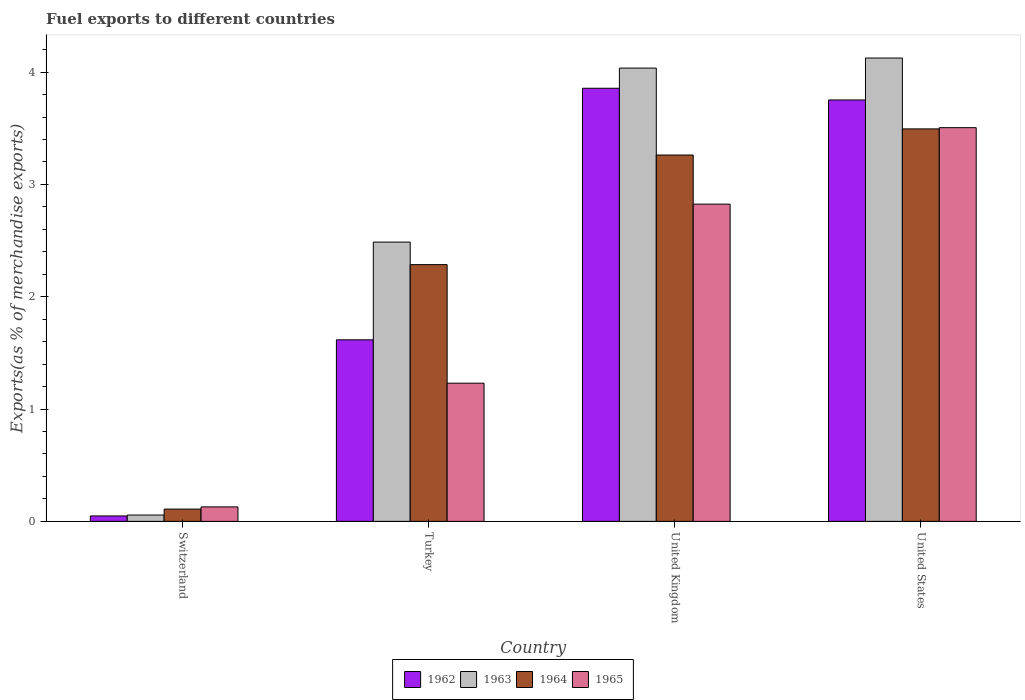Are the number of bars on each tick of the X-axis equal?
Offer a terse response. Yes. In how many cases, is the number of bars for a given country not equal to the number of legend labels?
Your answer should be compact. 0. What is the percentage of exports to different countries in 1965 in Turkey?
Your answer should be compact. 1.23. Across all countries, what is the maximum percentage of exports to different countries in 1962?
Offer a terse response. 3.86. Across all countries, what is the minimum percentage of exports to different countries in 1962?
Offer a very short reply. 0.05. In which country was the percentage of exports to different countries in 1962 maximum?
Make the answer very short. United Kingdom. In which country was the percentage of exports to different countries in 1962 minimum?
Ensure brevity in your answer.  Switzerland. What is the total percentage of exports to different countries in 1963 in the graph?
Offer a very short reply. 10.7. What is the difference between the percentage of exports to different countries in 1962 in Switzerland and that in United Kingdom?
Keep it short and to the point. -3.81. What is the difference between the percentage of exports to different countries in 1964 in United States and the percentage of exports to different countries in 1965 in United Kingdom?
Give a very brief answer. 0.67. What is the average percentage of exports to different countries in 1963 per country?
Make the answer very short. 2.68. What is the difference between the percentage of exports to different countries of/in 1965 and percentage of exports to different countries of/in 1963 in United States?
Make the answer very short. -0.62. What is the ratio of the percentage of exports to different countries in 1963 in Switzerland to that in United States?
Keep it short and to the point. 0.01. Is the difference between the percentage of exports to different countries in 1965 in Switzerland and United Kingdom greater than the difference between the percentage of exports to different countries in 1963 in Switzerland and United Kingdom?
Offer a terse response. Yes. What is the difference between the highest and the second highest percentage of exports to different countries in 1963?
Your response must be concise. -1.64. What is the difference between the highest and the lowest percentage of exports to different countries in 1962?
Provide a succinct answer. 3.81. In how many countries, is the percentage of exports to different countries in 1964 greater than the average percentage of exports to different countries in 1964 taken over all countries?
Your answer should be very brief. 2. What does the 4th bar from the left in United States represents?
Make the answer very short. 1965. What does the 3rd bar from the right in Switzerland represents?
Keep it short and to the point. 1963. How many countries are there in the graph?
Offer a terse response. 4. Are the values on the major ticks of Y-axis written in scientific E-notation?
Your answer should be very brief. No. Does the graph contain any zero values?
Offer a very short reply. No. Where does the legend appear in the graph?
Make the answer very short. Bottom center. How many legend labels are there?
Provide a short and direct response. 4. What is the title of the graph?
Keep it short and to the point. Fuel exports to different countries. What is the label or title of the X-axis?
Your answer should be compact. Country. What is the label or title of the Y-axis?
Make the answer very short. Exports(as % of merchandise exports). What is the Exports(as % of merchandise exports) of 1962 in Switzerland?
Provide a short and direct response. 0.05. What is the Exports(as % of merchandise exports) of 1963 in Switzerland?
Provide a succinct answer. 0.06. What is the Exports(as % of merchandise exports) of 1964 in Switzerland?
Offer a very short reply. 0.11. What is the Exports(as % of merchandise exports) in 1965 in Switzerland?
Make the answer very short. 0.13. What is the Exports(as % of merchandise exports) in 1962 in Turkey?
Give a very brief answer. 1.62. What is the Exports(as % of merchandise exports) in 1963 in Turkey?
Provide a succinct answer. 2.49. What is the Exports(as % of merchandise exports) of 1964 in Turkey?
Your response must be concise. 2.29. What is the Exports(as % of merchandise exports) in 1965 in Turkey?
Provide a succinct answer. 1.23. What is the Exports(as % of merchandise exports) of 1962 in United Kingdom?
Your answer should be compact. 3.86. What is the Exports(as % of merchandise exports) in 1963 in United Kingdom?
Your answer should be very brief. 4.04. What is the Exports(as % of merchandise exports) of 1964 in United Kingdom?
Offer a very short reply. 3.26. What is the Exports(as % of merchandise exports) in 1965 in United Kingdom?
Keep it short and to the point. 2.82. What is the Exports(as % of merchandise exports) of 1962 in United States?
Your answer should be very brief. 3.75. What is the Exports(as % of merchandise exports) in 1963 in United States?
Give a very brief answer. 4.13. What is the Exports(as % of merchandise exports) of 1964 in United States?
Offer a very short reply. 3.49. What is the Exports(as % of merchandise exports) in 1965 in United States?
Your answer should be very brief. 3.51. Across all countries, what is the maximum Exports(as % of merchandise exports) of 1962?
Provide a succinct answer. 3.86. Across all countries, what is the maximum Exports(as % of merchandise exports) in 1963?
Make the answer very short. 4.13. Across all countries, what is the maximum Exports(as % of merchandise exports) of 1964?
Your answer should be very brief. 3.49. Across all countries, what is the maximum Exports(as % of merchandise exports) of 1965?
Give a very brief answer. 3.51. Across all countries, what is the minimum Exports(as % of merchandise exports) in 1962?
Provide a short and direct response. 0.05. Across all countries, what is the minimum Exports(as % of merchandise exports) in 1963?
Offer a very short reply. 0.06. Across all countries, what is the minimum Exports(as % of merchandise exports) of 1964?
Offer a very short reply. 0.11. Across all countries, what is the minimum Exports(as % of merchandise exports) of 1965?
Keep it short and to the point. 0.13. What is the total Exports(as % of merchandise exports) of 1962 in the graph?
Your response must be concise. 9.27. What is the total Exports(as % of merchandise exports) of 1963 in the graph?
Keep it short and to the point. 10.7. What is the total Exports(as % of merchandise exports) in 1964 in the graph?
Your answer should be very brief. 9.15. What is the total Exports(as % of merchandise exports) of 1965 in the graph?
Your answer should be compact. 7.69. What is the difference between the Exports(as % of merchandise exports) of 1962 in Switzerland and that in Turkey?
Your answer should be very brief. -1.57. What is the difference between the Exports(as % of merchandise exports) of 1963 in Switzerland and that in Turkey?
Your response must be concise. -2.43. What is the difference between the Exports(as % of merchandise exports) in 1964 in Switzerland and that in Turkey?
Ensure brevity in your answer.  -2.18. What is the difference between the Exports(as % of merchandise exports) of 1965 in Switzerland and that in Turkey?
Keep it short and to the point. -1.1. What is the difference between the Exports(as % of merchandise exports) in 1962 in Switzerland and that in United Kingdom?
Keep it short and to the point. -3.81. What is the difference between the Exports(as % of merchandise exports) of 1963 in Switzerland and that in United Kingdom?
Provide a succinct answer. -3.98. What is the difference between the Exports(as % of merchandise exports) in 1964 in Switzerland and that in United Kingdom?
Your response must be concise. -3.15. What is the difference between the Exports(as % of merchandise exports) of 1965 in Switzerland and that in United Kingdom?
Give a very brief answer. -2.7. What is the difference between the Exports(as % of merchandise exports) in 1962 in Switzerland and that in United States?
Your response must be concise. -3.7. What is the difference between the Exports(as % of merchandise exports) of 1963 in Switzerland and that in United States?
Your response must be concise. -4.07. What is the difference between the Exports(as % of merchandise exports) in 1964 in Switzerland and that in United States?
Offer a very short reply. -3.39. What is the difference between the Exports(as % of merchandise exports) of 1965 in Switzerland and that in United States?
Offer a very short reply. -3.38. What is the difference between the Exports(as % of merchandise exports) of 1962 in Turkey and that in United Kingdom?
Make the answer very short. -2.24. What is the difference between the Exports(as % of merchandise exports) in 1963 in Turkey and that in United Kingdom?
Keep it short and to the point. -1.55. What is the difference between the Exports(as % of merchandise exports) of 1964 in Turkey and that in United Kingdom?
Provide a short and direct response. -0.98. What is the difference between the Exports(as % of merchandise exports) of 1965 in Turkey and that in United Kingdom?
Your answer should be very brief. -1.59. What is the difference between the Exports(as % of merchandise exports) in 1962 in Turkey and that in United States?
Offer a very short reply. -2.14. What is the difference between the Exports(as % of merchandise exports) of 1963 in Turkey and that in United States?
Make the answer very short. -1.64. What is the difference between the Exports(as % of merchandise exports) in 1964 in Turkey and that in United States?
Your response must be concise. -1.21. What is the difference between the Exports(as % of merchandise exports) in 1965 in Turkey and that in United States?
Your answer should be very brief. -2.27. What is the difference between the Exports(as % of merchandise exports) of 1962 in United Kingdom and that in United States?
Keep it short and to the point. 0.1. What is the difference between the Exports(as % of merchandise exports) in 1963 in United Kingdom and that in United States?
Offer a terse response. -0.09. What is the difference between the Exports(as % of merchandise exports) of 1964 in United Kingdom and that in United States?
Your answer should be very brief. -0.23. What is the difference between the Exports(as % of merchandise exports) in 1965 in United Kingdom and that in United States?
Your answer should be very brief. -0.68. What is the difference between the Exports(as % of merchandise exports) in 1962 in Switzerland and the Exports(as % of merchandise exports) in 1963 in Turkey?
Your answer should be very brief. -2.44. What is the difference between the Exports(as % of merchandise exports) of 1962 in Switzerland and the Exports(as % of merchandise exports) of 1964 in Turkey?
Provide a short and direct response. -2.24. What is the difference between the Exports(as % of merchandise exports) in 1962 in Switzerland and the Exports(as % of merchandise exports) in 1965 in Turkey?
Your answer should be very brief. -1.18. What is the difference between the Exports(as % of merchandise exports) of 1963 in Switzerland and the Exports(as % of merchandise exports) of 1964 in Turkey?
Your response must be concise. -2.23. What is the difference between the Exports(as % of merchandise exports) of 1963 in Switzerland and the Exports(as % of merchandise exports) of 1965 in Turkey?
Ensure brevity in your answer.  -1.17. What is the difference between the Exports(as % of merchandise exports) in 1964 in Switzerland and the Exports(as % of merchandise exports) in 1965 in Turkey?
Your response must be concise. -1.12. What is the difference between the Exports(as % of merchandise exports) of 1962 in Switzerland and the Exports(as % of merchandise exports) of 1963 in United Kingdom?
Your response must be concise. -3.99. What is the difference between the Exports(as % of merchandise exports) of 1962 in Switzerland and the Exports(as % of merchandise exports) of 1964 in United Kingdom?
Provide a short and direct response. -3.21. What is the difference between the Exports(as % of merchandise exports) of 1962 in Switzerland and the Exports(as % of merchandise exports) of 1965 in United Kingdom?
Your answer should be compact. -2.78. What is the difference between the Exports(as % of merchandise exports) in 1963 in Switzerland and the Exports(as % of merchandise exports) in 1964 in United Kingdom?
Ensure brevity in your answer.  -3.21. What is the difference between the Exports(as % of merchandise exports) of 1963 in Switzerland and the Exports(as % of merchandise exports) of 1965 in United Kingdom?
Your answer should be very brief. -2.77. What is the difference between the Exports(as % of merchandise exports) of 1964 in Switzerland and the Exports(as % of merchandise exports) of 1965 in United Kingdom?
Offer a terse response. -2.72. What is the difference between the Exports(as % of merchandise exports) in 1962 in Switzerland and the Exports(as % of merchandise exports) in 1963 in United States?
Keep it short and to the point. -4.08. What is the difference between the Exports(as % of merchandise exports) in 1962 in Switzerland and the Exports(as % of merchandise exports) in 1964 in United States?
Offer a very short reply. -3.45. What is the difference between the Exports(as % of merchandise exports) of 1962 in Switzerland and the Exports(as % of merchandise exports) of 1965 in United States?
Offer a terse response. -3.46. What is the difference between the Exports(as % of merchandise exports) in 1963 in Switzerland and the Exports(as % of merchandise exports) in 1964 in United States?
Keep it short and to the point. -3.44. What is the difference between the Exports(as % of merchandise exports) in 1963 in Switzerland and the Exports(as % of merchandise exports) in 1965 in United States?
Your answer should be compact. -3.45. What is the difference between the Exports(as % of merchandise exports) of 1964 in Switzerland and the Exports(as % of merchandise exports) of 1965 in United States?
Provide a succinct answer. -3.4. What is the difference between the Exports(as % of merchandise exports) of 1962 in Turkey and the Exports(as % of merchandise exports) of 1963 in United Kingdom?
Provide a short and direct response. -2.42. What is the difference between the Exports(as % of merchandise exports) in 1962 in Turkey and the Exports(as % of merchandise exports) in 1964 in United Kingdom?
Ensure brevity in your answer.  -1.65. What is the difference between the Exports(as % of merchandise exports) in 1962 in Turkey and the Exports(as % of merchandise exports) in 1965 in United Kingdom?
Make the answer very short. -1.21. What is the difference between the Exports(as % of merchandise exports) in 1963 in Turkey and the Exports(as % of merchandise exports) in 1964 in United Kingdom?
Give a very brief answer. -0.78. What is the difference between the Exports(as % of merchandise exports) of 1963 in Turkey and the Exports(as % of merchandise exports) of 1965 in United Kingdom?
Offer a terse response. -0.34. What is the difference between the Exports(as % of merchandise exports) in 1964 in Turkey and the Exports(as % of merchandise exports) in 1965 in United Kingdom?
Offer a very short reply. -0.54. What is the difference between the Exports(as % of merchandise exports) in 1962 in Turkey and the Exports(as % of merchandise exports) in 1963 in United States?
Keep it short and to the point. -2.51. What is the difference between the Exports(as % of merchandise exports) in 1962 in Turkey and the Exports(as % of merchandise exports) in 1964 in United States?
Your answer should be compact. -1.88. What is the difference between the Exports(as % of merchandise exports) in 1962 in Turkey and the Exports(as % of merchandise exports) in 1965 in United States?
Ensure brevity in your answer.  -1.89. What is the difference between the Exports(as % of merchandise exports) of 1963 in Turkey and the Exports(as % of merchandise exports) of 1964 in United States?
Keep it short and to the point. -1.01. What is the difference between the Exports(as % of merchandise exports) of 1963 in Turkey and the Exports(as % of merchandise exports) of 1965 in United States?
Your response must be concise. -1.02. What is the difference between the Exports(as % of merchandise exports) in 1964 in Turkey and the Exports(as % of merchandise exports) in 1965 in United States?
Give a very brief answer. -1.22. What is the difference between the Exports(as % of merchandise exports) of 1962 in United Kingdom and the Exports(as % of merchandise exports) of 1963 in United States?
Your response must be concise. -0.27. What is the difference between the Exports(as % of merchandise exports) of 1962 in United Kingdom and the Exports(as % of merchandise exports) of 1964 in United States?
Offer a terse response. 0.36. What is the difference between the Exports(as % of merchandise exports) of 1962 in United Kingdom and the Exports(as % of merchandise exports) of 1965 in United States?
Keep it short and to the point. 0.35. What is the difference between the Exports(as % of merchandise exports) of 1963 in United Kingdom and the Exports(as % of merchandise exports) of 1964 in United States?
Offer a terse response. 0.54. What is the difference between the Exports(as % of merchandise exports) of 1963 in United Kingdom and the Exports(as % of merchandise exports) of 1965 in United States?
Keep it short and to the point. 0.53. What is the difference between the Exports(as % of merchandise exports) in 1964 in United Kingdom and the Exports(as % of merchandise exports) in 1965 in United States?
Give a very brief answer. -0.24. What is the average Exports(as % of merchandise exports) in 1962 per country?
Your response must be concise. 2.32. What is the average Exports(as % of merchandise exports) in 1963 per country?
Your answer should be compact. 2.68. What is the average Exports(as % of merchandise exports) in 1964 per country?
Give a very brief answer. 2.29. What is the average Exports(as % of merchandise exports) in 1965 per country?
Give a very brief answer. 1.92. What is the difference between the Exports(as % of merchandise exports) in 1962 and Exports(as % of merchandise exports) in 1963 in Switzerland?
Provide a short and direct response. -0.01. What is the difference between the Exports(as % of merchandise exports) of 1962 and Exports(as % of merchandise exports) of 1964 in Switzerland?
Ensure brevity in your answer.  -0.06. What is the difference between the Exports(as % of merchandise exports) of 1962 and Exports(as % of merchandise exports) of 1965 in Switzerland?
Your answer should be very brief. -0.08. What is the difference between the Exports(as % of merchandise exports) of 1963 and Exports(as % of merchandise exports) of 1964 in Switzerland?
Make the answer very short. -0.05. What is the difference between the Exports(as % of merchandise exports) of 1963 and Exports(as % of merchandise exports) of 1965 in Switzerland?
Offer a terse response. -0.07. What is the difference between the Exports(as % of merchandise exports) of 1964 and Exports(as % of merchandise exports) of 1965 in Switzerland?
Keep it short and to the point. -0.02. What is the difference between the Exports(as % of merchandise exports) of 1962 and Exports(as % of merchandise exports) of 1963 in Turkey?
Your answer should be very brief. -0.87. What is the difference between the Exports(as % of merchandise exports) in 1962 and Exports(as % of merchandise exports) in 1964 in Turkey?
Your answer should be very brief. -0.67. What is the difference between the Exports(as % of merchandise exports) of 1962 and Exports(as % of merchandise exports) of 1965 in Turkey?
Offer a terse response. 0.39. What is the difference between the Exports(as % of merchandise exports) of 1963 and Exports(as % of merchandise exports) of 1964 in Turkey?
Your answer should be compact. 0.2. What is the difference between the Exports(as % of merchandise exports) in 1963 and Exports(as % of merchandise exports) in 1965 in Turkey?
Provide a succinct answer. 1.26. What is the difference between the Exports(as % of merchandise exports) of 1964 and Exports(as % of merchandise exports) of 1965 in Turkey?
Ensure brevity in your answer.  1.06. What is the difference between the Exports(as % of merchandise exports) of 1962 and Exports(as % of merchandise exports) of 1963 in United Kingdom?
Your answer should be compact. -0.18. What is the difference between the Exports(as % of merchandise exports) in 1962 and Exports(as % of merchandise exports) in 1964 in United Kingdom?
Offer a very short reply. 0.59. What is the difference between the Exports(as % of merchandise exports) of 1962 and Exports(as % of merchandise exports) of 1965 in United Kingdom?
Give a very brief answer. 1.03. What is the difference between the Exports(as % of merchandise exports) of 1963 and Exports(as % of merchandise exports) of 1964 in United Kingdom?
Your answer should be very brief. 0.77. What is the difference between the Exports(as % of merchandise exports) in 1963 and Exports(as % of merchandise exports) in 1965 in United Kingdom?
Your answer should be very brief. 1.21. What is the difference between the Exports(as % of merchandise exports) of 1964 and Exports(as % of merchandise exports) of 1965 in United Kingdom?
Your answer should be very brief. 0.44. What is the difference between the Exports(as % of merchandise exports) of 1962 and Exports(as % of merchandise exports) of 1963 in United States?
Keep it short and to the point. -0.37. What is the difference between the Exports(as % of merchandise exports) in 1962 and Exports(as % of merchandise exports) in 1964 in United States?
Offer a very short reply. 0.26. What is the difference between the Exports(as % of merchandise exports) in 1962 and Exports(as % of merchandise exports) in 1965 in United States?
Your answer should be compact. 0.25. What is the difference between the Exports(as % of merchandise exports) of 1963 and Exports(as % of merchandise exports) of 1964 in United States?
Your response must be concise. 0.63. What is the difference between the Exports(as % of merchandise exports) in 1963 and Exports(as % of merchandise exports) in 1965 in United States?
Give a very brief answer. 0.62. What is the difference between the Exports(as % of merchandise exports) of 1964 and Exports(as % of merchandise exports) of 1965 in United States?
Your answer should be very brief. -0.01. What is the ratio of the Exports(as % of merchandise exports) of 1962 in Switzerland to that in Turkey?
Ensure brevity in your answer.  0.03. What is the ratio of the Exports(as % of merchandise exports) of 1963 in Switzerland to that in Turkey?
Give a very brief answer. 0.02. What is the ratio of the Exports(as % of merchandise exports) in 1964 in Switzerland to that in Turkey?
Offer a terse response. 0.05. What is the ratio of the Exports(as % of merchandise exports) of 1965 in Switzerland to that in Turkey?
Your answer should be very brief. 0.1. What is the ratio of the Exports(as % of merchandise exports) in 1962 in Switzerland to that in United Kingdom?
Ensure brevity in your answer.  0.01. What is the ratio of the Exports(as % of merchandise exports) in 1963 in Switzerland to that in United Kingdom?
Keep it short and to the point. 0.01. What is the ratio of the Exports(as % of merchandise exports) in 1964 in Switzerland to that in United Kingdom?
Your answer should be very brief. 0.03. What is the ratio of the Exports(as % of merchandise exports) in 1965 in Switzerland to that in United Kingdom?
Your answer should be compact. 0.05. What is the ratio of the Exports(as % of merchandise exports) of 1962 in Switzerland to that in United States?
Make the answer very short. 0.01. What is the ratio of the Exports(as % of merchandise exports) of 1963 in Switzerland to that in United States?
Provide a succinct answer. 0.01. What is the ratio of the Exports(as % of merchandise exports) of 1964 in Switzerland to that in United States?
Make the answer very short. 0.03. What is the ratio of the Exports(as % of merchandise exports) in 1965 in Switzerland to that in United States?
Offer a very short reply. 0.04. What is the ratio of the Exports(as % of merchandise exports) in 1962 in Turkey to that in United Kingdom?
Offer a terse response. 0.42. What is the ratio of the Exports(as % of merchandise exports) of 1963 in Turkey to that in United Kingdom?
Your answer should be compact. 0.62. What is the ratio of the Exports(as % of merchandise exports) in 1964 in Turkey to that in United Kingdom?
Make the answer very short. 0.7. What is the ratio of the Exports(as % of merchandise exports) in 1965 in Turkey to that in United Kingdom?
Make the answer very short. 0.44. What is the ratio of the Exports(as % of merchandise exports) of 1962 in Turkey to that in United States?
Offer a terse response. 0.43. What is the ratio of the Exports(as % of merchandise exports) in 1963 in Turkey to that in United States?
Ensure brevity in your answer.  0.6. What is the ratio of the Exports(as % of merchandise exports) of 1964 in Turkey to that in United States?
Your response must be concise. 0.65. What is the ratio of the Exports(as % of merchandise exports) in 1965 in Turkey to that in United States?
Offer a terse response. 0.35. What is the ratio of the Exports(as % of merchandise exports) in 1962 in United Kingdom to that in United States?
Provide a succinct answer. 1.03. What is the ratio of the Exports(as % of merchandise exports) of 1963 in United Kingdom to that in United States?
Make the answer very short. 0.98. What is the ratio of the Exports(as % of merchandise exports) of 1964 in United Kingdom to that in United States?
Ensure brevity in your answer.  0.93. What is the ratio of the Exports(as % of merchandise exports) in 1965 in United Kingdom to that in United States?
Keep it short and to the point. 0.81. What is the difference between the highest and the second highest Exports(as % of merchandise exports) in 1962?
Give a very brief answer. 0.1. What is the difference between the highest and the second highest Exports(as % of merchandise exports) in 1963?
Provide a short and direct response. 0.09. What is the difference between the highest and the second highest Exports(as % of merchandise exports) in 1964?
Offer a terse response. 0.23. What is the difference between the highest and the second highest Exports(as % of merchandise exports) in 1965?
Offer a terse response. 0.68. What is the difference between the highest and the lowest Exports(as % of merchandise exports) in 1962?
Your answer should be very brief. 3.81. What is the difference between the highest and the lowest Exports(as % of merchandise exports) of 1963?
Your response must be concise. 4.07. What is the difference between the highest and the lowest Exports(as % of merchandise exports) of 1964?
Offer a terse response. 3.39. What is the difference between the highest and the lowest Exports(as % of merchandise exports) of 1965?
Ensure brevity in your answer.  3.38. 